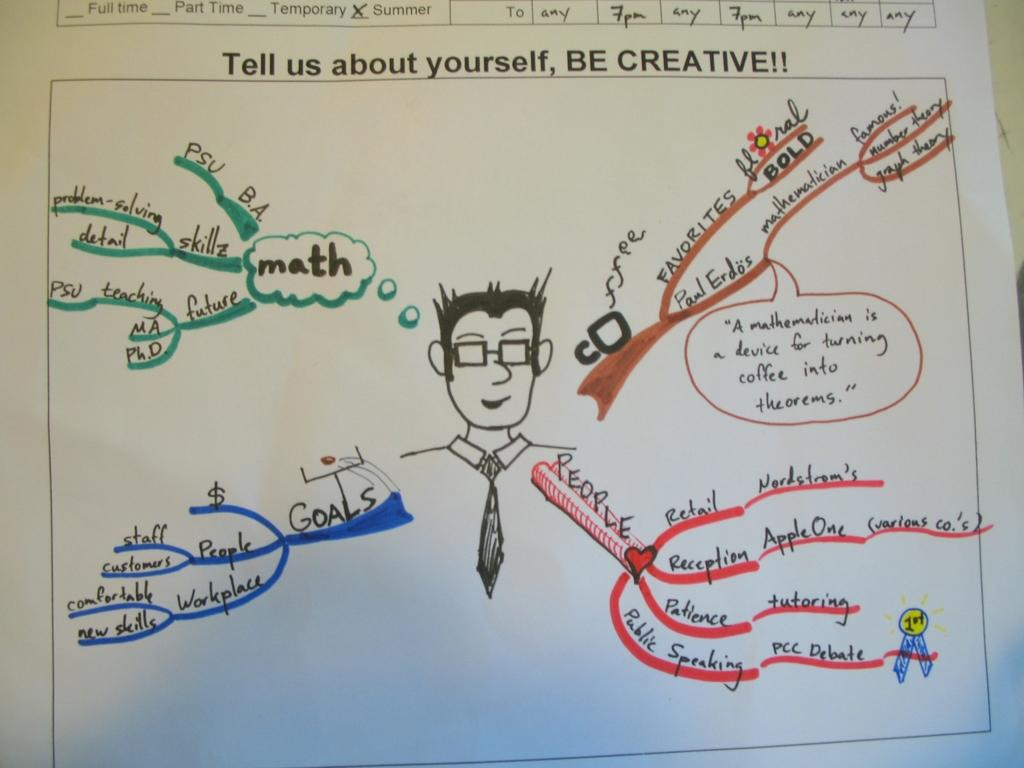What is present in the image? There is a paper in the image. What is depicted on the paper? The paper contains a diagram of a person. Are there any words or symbols on the paper? Yes, the paper contains text. What type of stew is being served in the image? There is no stew present in the image; it only contains a paper with a diagram of a person and text. How many teeth can be seen in the image? There are no teeth visible in the image, as it features a paper with a diagram of a person and text. 